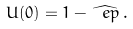Convert formula to latex. <formula><loc_0><loc_0><loc_500><loc_500>U ( 0 ) = 1 - \widehat { \ e p } \, .</formula> 